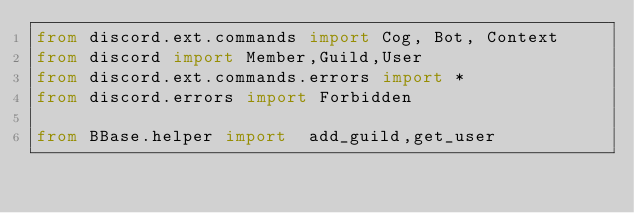Convert code to text. <code><loc_0><loc_0><loc_500><loc_500><_Python_>from discord.ext.commands import Cog, Bot, Context
from discord import Member,Guild,User
from discord.ext.commands.errors import *
from discord.errors import Forbidden

from BBase.helper import  add_guild,get_user</code> 